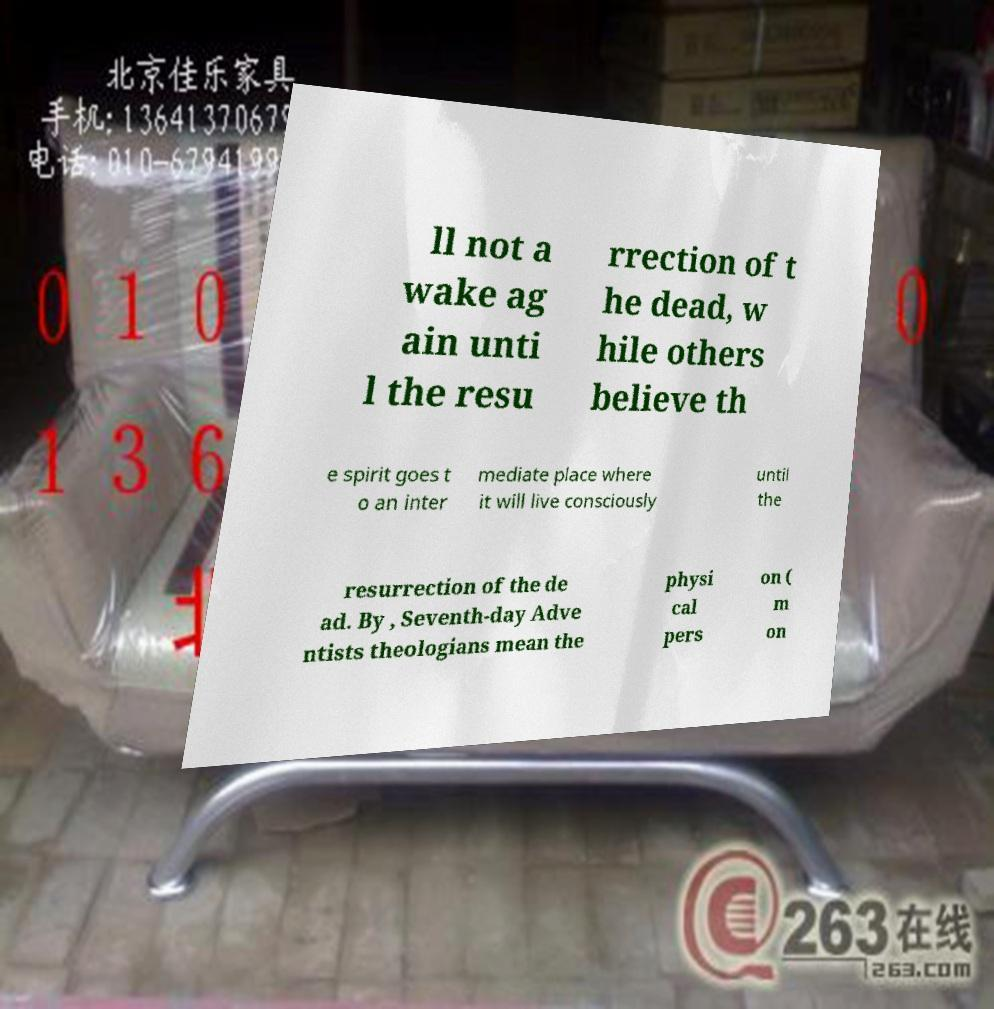Please identify and transcribe the text found in this image. ll not a wake ag ain unti l the resu rrection of t he dead, w hile others believe th e spirit goes t o an inter mediate place where it will live consciously until the resurrection of the de ad. By , Seventh-day Adve ntists theologians mean the physi cal pers on ( m on 